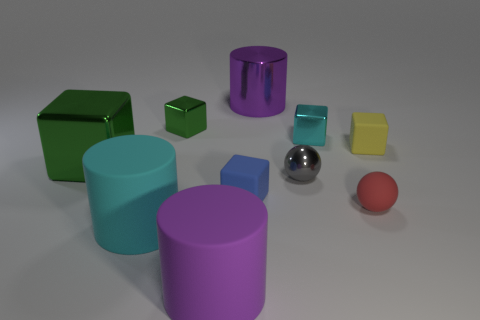Subtract all big green metallic cubes. How many cubes are left? 4 Subtract all blue cubes. How many cubes are left? 4 Subtract all brown cubes. Subtract all brown balls. How many cubes are left? 5 Subtract all balls. How many objects are left? 8 Add 9 big green shiny cylinders. How many big green shiny cylinders exist? 9 Subtract 0 gray blocks. How many objects are left? 10 Subtract all large cyan metal cylinders. Subtract all tiny green objects. How many objects are left? 9 Add 7 purple things. How many purple things are left? 9 